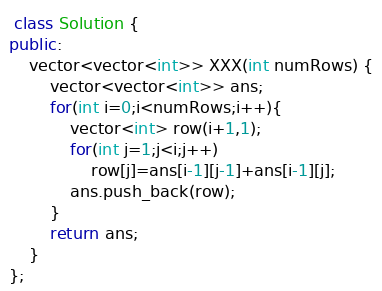<code> <loc_0><loc_0><loc_500><loc_500><_C++_> class Solution {
public:
    vector<vector<int>> XXX(int numRows) {
        vector<vector<int>> ans;
        for(int i=0;i<numRows;i++){
            vector<int> row(i+1,1);
            for(int j=1;j<i;j++)
                row[j]=ans[i-1][j-1]+ans[i-1][j];
            ans.push_back(row);
        }
        return ans;
    }
};

</code> 